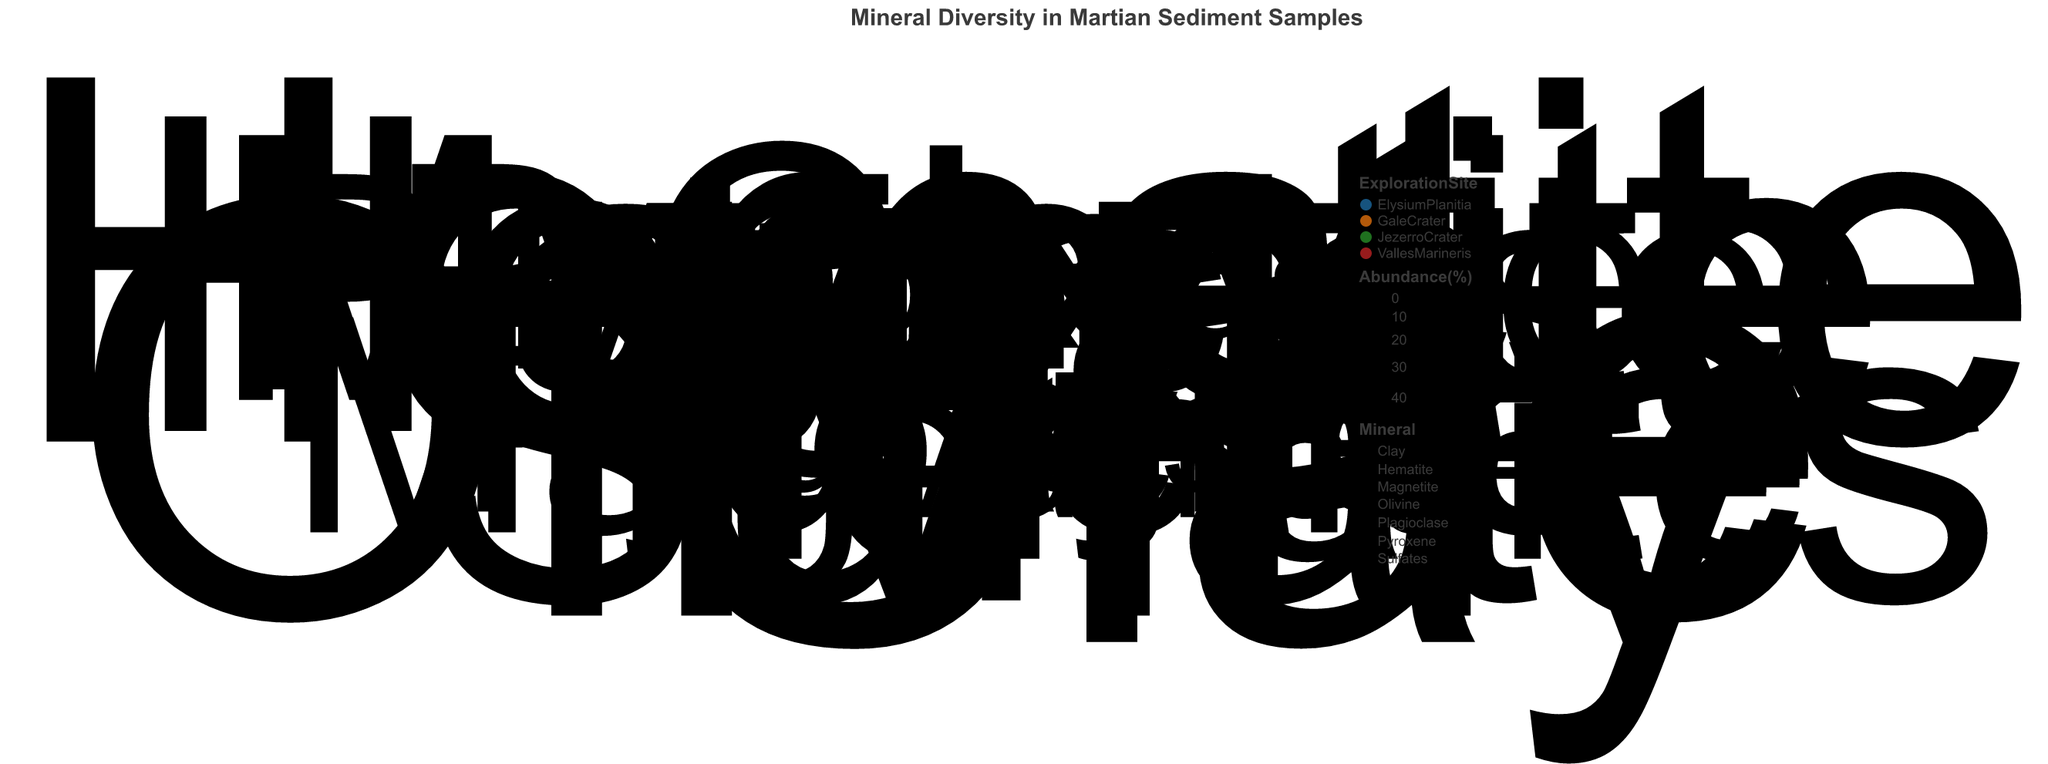What's the title of the chart? The title of the figure is displayed at the top and provides a descriptive name for the visualized data.
Answer: “Mineral Diversity in Martian Sediment Samples” Which site has the highest abundance of Clay? Identify the size of the points labeled "Clay" and find the largest one. Valles Marineris has the largest point labeled "Clay".
Answer: Valles Marineris What is the abundance of Hematite in Elysium Planitia? Locate the point labeled "Hematite" at Elysium Planitia and check its size. The chart indicates it has an abundance of 35%.
Answer: 35% Which mineral is most abundant in Jezerro Crater? Check the size of all points at Jezerro Crater and identify the largest one. The largest point belongs to "Olivine" with an abundance of 40%.
Answer: Olivine Which exploration site shows the highest variety of minerals? Count the different minerals represented by points at each exploration site. Gale Crater and Jezerro Crater both show a variety of 5 different minerals.
Answer: Gale Crater and Jezerro Crater How does the abundance of Magnetite compare between Gale Crater and Elysium Planitia? Identify and compare the sizes of the Magnetite points at both Gale Crater and Elysium Planitia. Gale Crater has 15%, while Elysium Planitia has 25%.
Answer: Elysium Planitia has a higher abundance What is the average abundance of minerals at Valles Marineris? Sum up the abundances of minerals at Valles Marineris and divide by the number of minerals. (20 + 10 + 30 + 40) / 4 = 25%.
Answer: 25% Which mineral appears at the most exploration sites? Identify and count the occurrences of each mineral across all exploration sites. Hematite and Magnetite both appear in three different sites.
Answer: Hematite and Magnetite How many exploration sites contain Sulfates? Count the number of distinct exploration sites that have points labeled "Sulfates". The sites are Jezerro Crater and Valles Marineris.
Answer: 2 